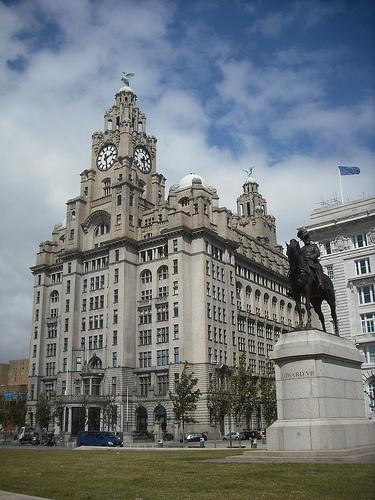How many flags are there in the scene and what are their colors? There are two flags - one European flag and one blue flag on a white pole. Is there any writing on the base of the brown statue? Yes, there is writing on the base of the brown statue. Describe the noteworthy natural elements found in the image. A group of trees, green grass by the statue, cloudy blue sky, and white clouds against the blue sky. Mention the colors and types of vehicles found on the street in the image. Blue van, black car, silver car, and a golf cart. What is situated on top of the brown statue's foundation? A brown statue of a person mounted on a horse. Identify and describe the object interacting with the large beige building. A gray sedan car is parked by the beige hotel building, interacting with it from a parking standpoint. What type of statue is situated near the green grass? A bronze statue of a person mounted on a horse. What color is the car parked close to the beige hotel building? The car is a gray sedan. Identify the building with the most windows mentioned in the image and give a brief description. A large beige building with many windows, likely a hotel, and architectural features like pillars and a white dome. What kind of clock is located in the tower and what color is the tower? A black and white clock is in the tower, and the tower is brown. Pay attention to the couple taking a selfie in front of the clock tower. No, it's not mentioned in the image. 